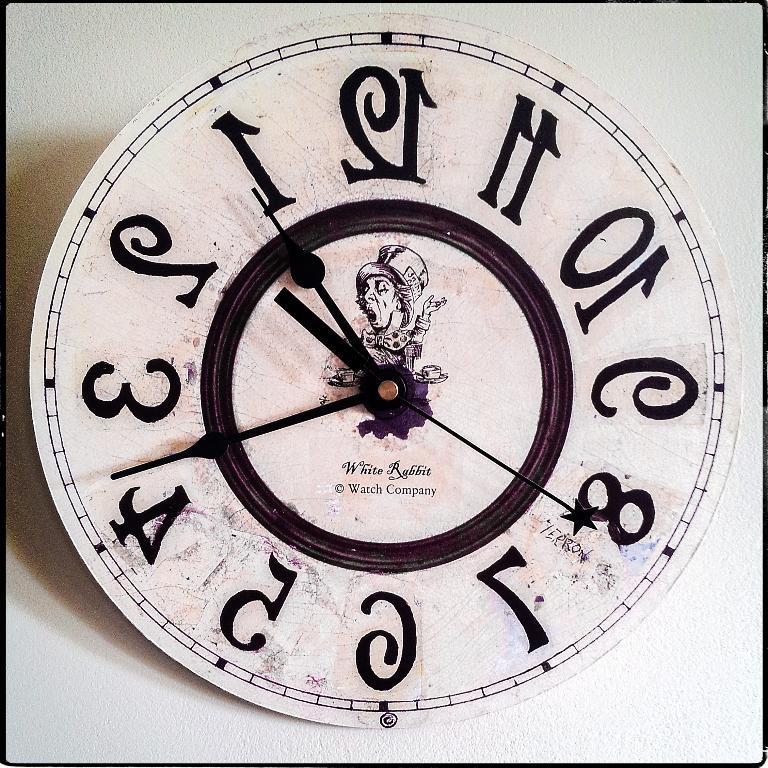What object in the image displays the time? There is a clock in the image that displays the time. What features are present on the clock? The clock has text and numbers on it. What type of image can be seen in the image? There is a cartoon image in the image. What type of creature is responsible for the station's cleanliness in the image? There is no mention of a station or a creature responsible for cleanliness in the image. 